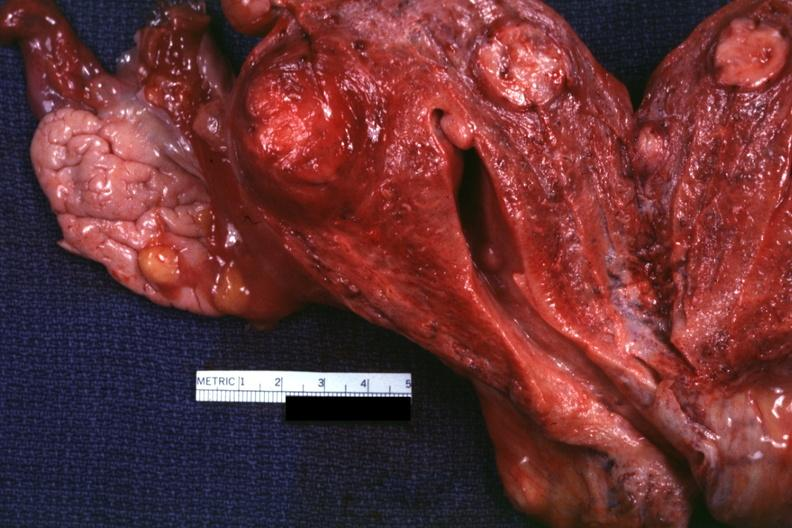s supernumerary digit present?
Answer the question using a single word or phrase. No 